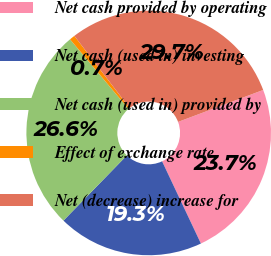<chart> <loc_0><loc_0><loc_500><loc_500><pie_chart><fcel>Net cash provided by operating<fcel>Net cash (used in) investing<fcel>Net cash (used in) provided by<fcel>Effect of exchange rate<fcel>Net (decrease) increase for<nl><fcel>23.7%<fcel>19.3%<fcel>26.6%<fcel>0.72%<fcel>29.69%<nl></chart> 